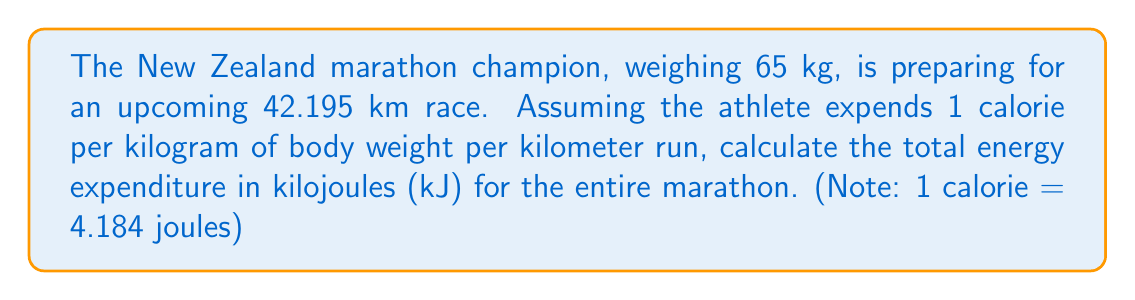What is the answer to this math problem? Let's approach this problem step by step:

1. Calculate the total calories expended:
   $$\text{Calories} = \text{Weight} \times \text{Distance} \times \text{Calorie per kg per km}$$
   $$\text{Calories} = 65 \text{ kg} \times 42.195 \text{ km} \times 1 \text{ cal/(kg·km)} = 2742.675 \text{ cal}$$

2. Convert calories to joules:
   $$\text{Joules} = \text{Calories} \times 4.184 \text{ J/cal}$$
   $$\text{Joules} = 2742.675 \text{ cal} \times 4.184 \text{ J/cal} = 11473.351 \text{ J}$$

3. Convert joules to kilojoules:
   $$\text{Kilojoules} = \frac{\text{Joules}}{1000}$$
   $$\text{Kilojoules} = \frac{11473.351 \text{ J}}{1000} = 11.473351 \text{ kJ}$$

4. Round to three decimal places:
   $$\text{Energy Expenditure} \approx 11.473 \text{ kJ}$$
Answer: 11.473 kJ 